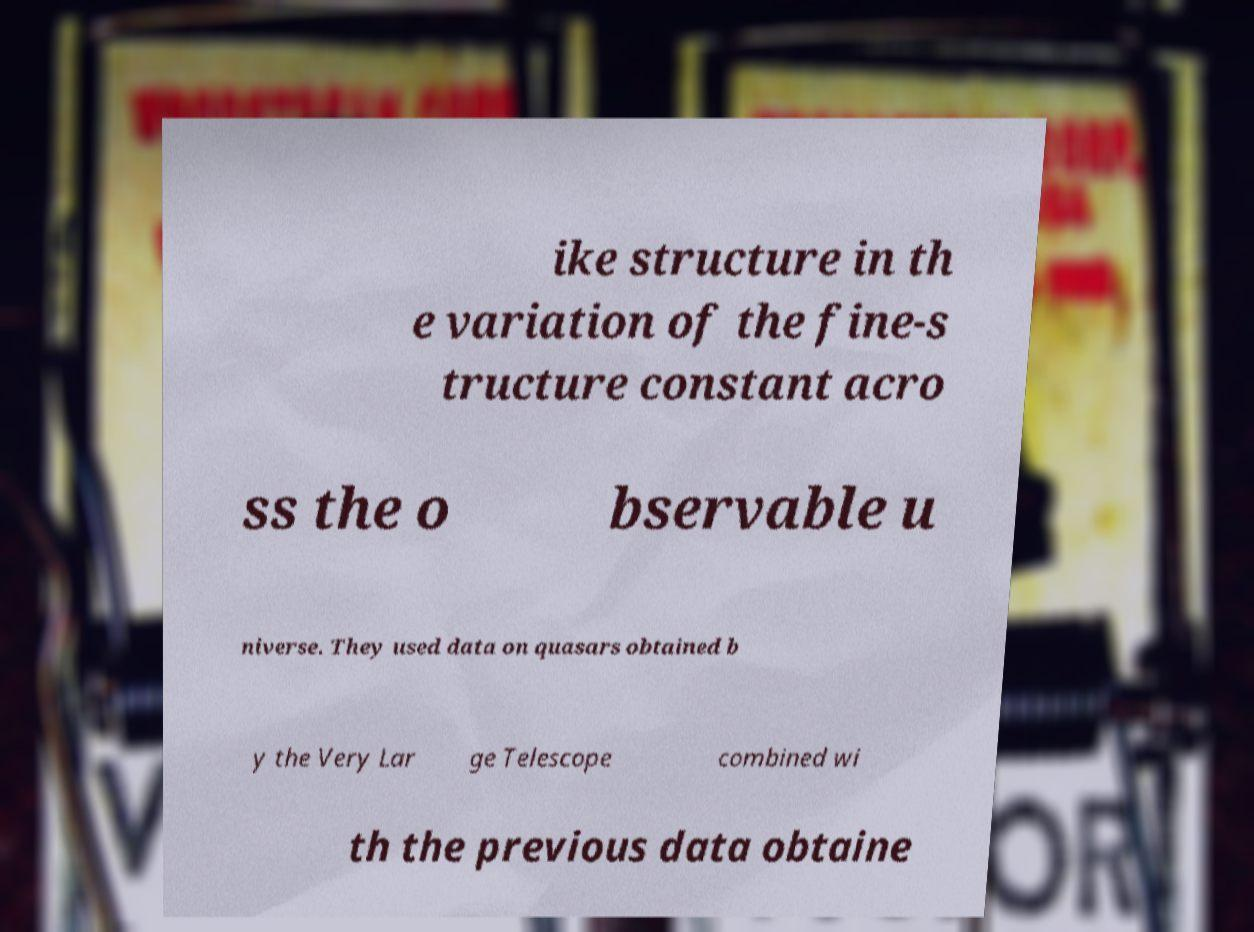Please identify and transcribe the text found in this image. ike structure in th e variation of the fine-s tructure constant acro ss the o bservable u niverse. They used data on quasars obtained b y the Very Lar ge Telescope combined wi th the previous data obtaine 